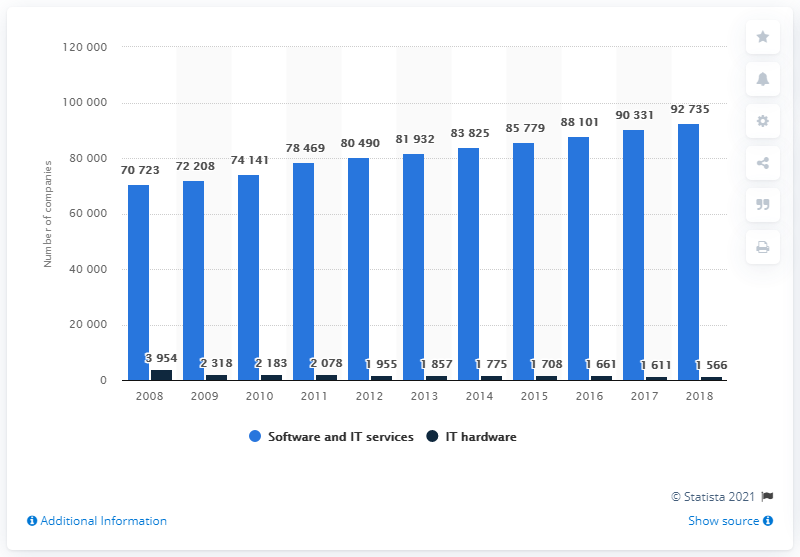Indicate a few pertinent items in this graphic. In 2018, there were approximately 92,735 companies in the software and IT services segment in Germany. 